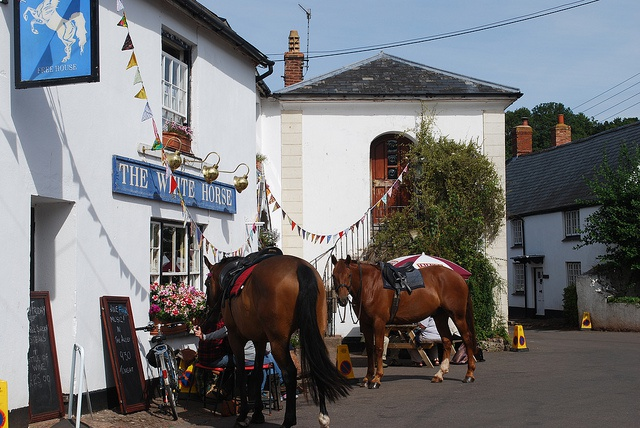Describe the objects in this image and their specific colors. I can see horse in lightblue, black, maroon, and gray tones, horse in lightblue, black, maroon, brown, and gray tones, and bicycle in lightblue, black, gray, darkgray, and maroon tones in this image. 